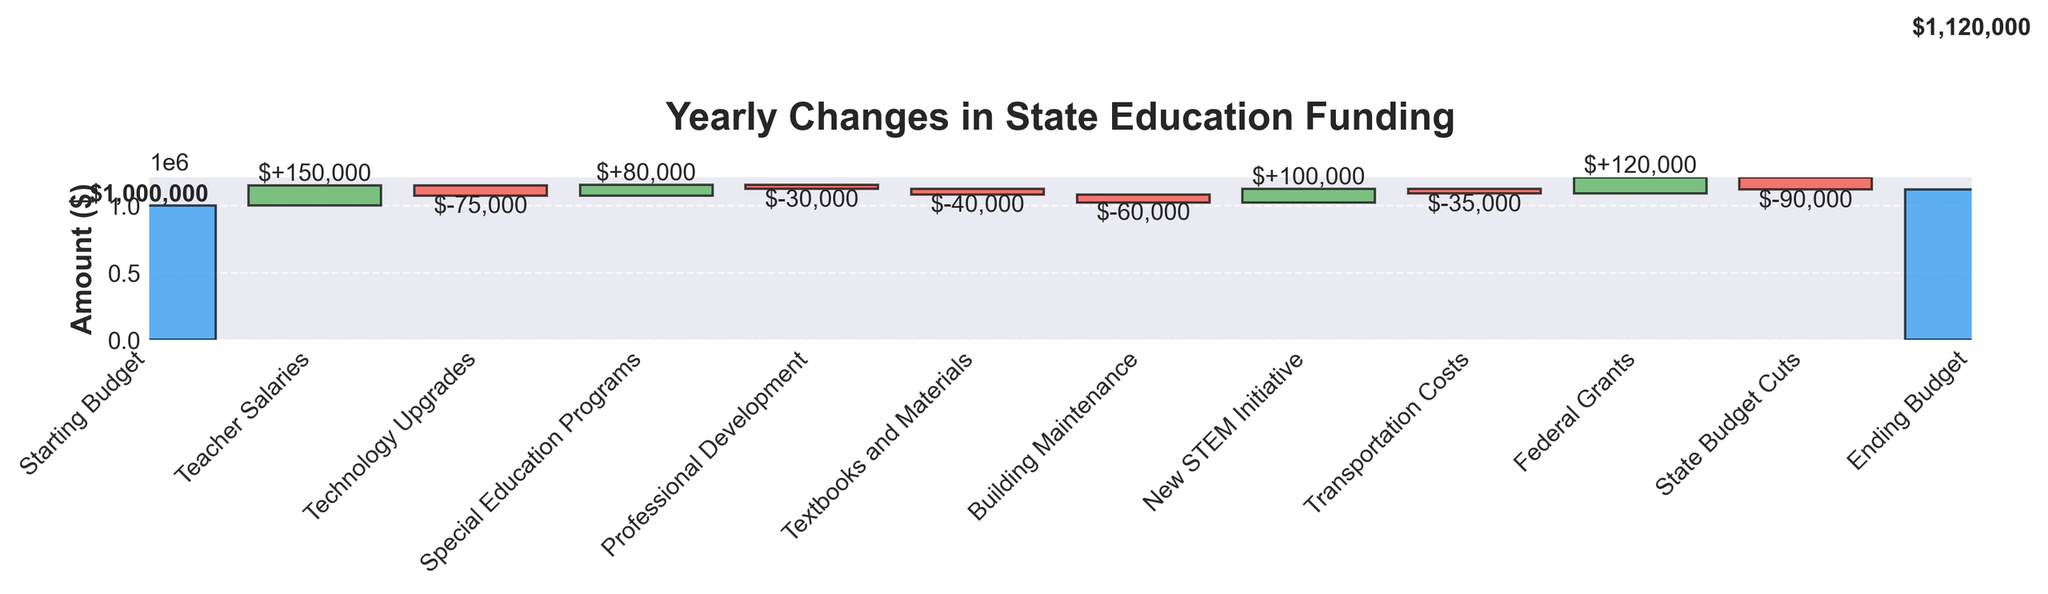what is the title of the figure? The title is usually displayed at the top of the chart. In this case, it reads "Yearly Changes in State Education Funding."
Answer: Yearly Changes in State Education Funding Which category has the highest positive value? The highest positive value is determined by comparing the positive changes in the different allocations. "New STEM Initiative" has a value of +100,000.
Answer: New STEM Initiative Which category had the most negative impact on the budget? By examining the bars with negative values, we can see that "Technology Upgrades" at -75,000 had the most negative impact.
Answer: Technology Upgrades What was the net effect of the federal grants and state budget cuts? Federal Grants contributed +120,000 while State Budget Cuts deducted -90,000. Summing these values provides the net effect: 120,000 - 90,000 = 30,000.
Answer: 30,000 How much did the professional development allocation change the budget? The Professional Development allocation appears as a negative change of -30,000, indicating it reduced the budget by this amount.
Answer: -30,000 How did teacher salaries contribute to the budget change? Teacher Salaries show a positive change with a value of +150,000, meaning they increased the budget by this amount.
Answer: +150,000 What was the ending budget, and how does it compare to the starting budget? The starting budget is given as 1,000,000. The ending budget is shown as 1,120,000. The difference between the two is 1,120,000 - 1,000,000 = 120,000, indicating an increase of 120,000.
Answer: increased by 120,000 